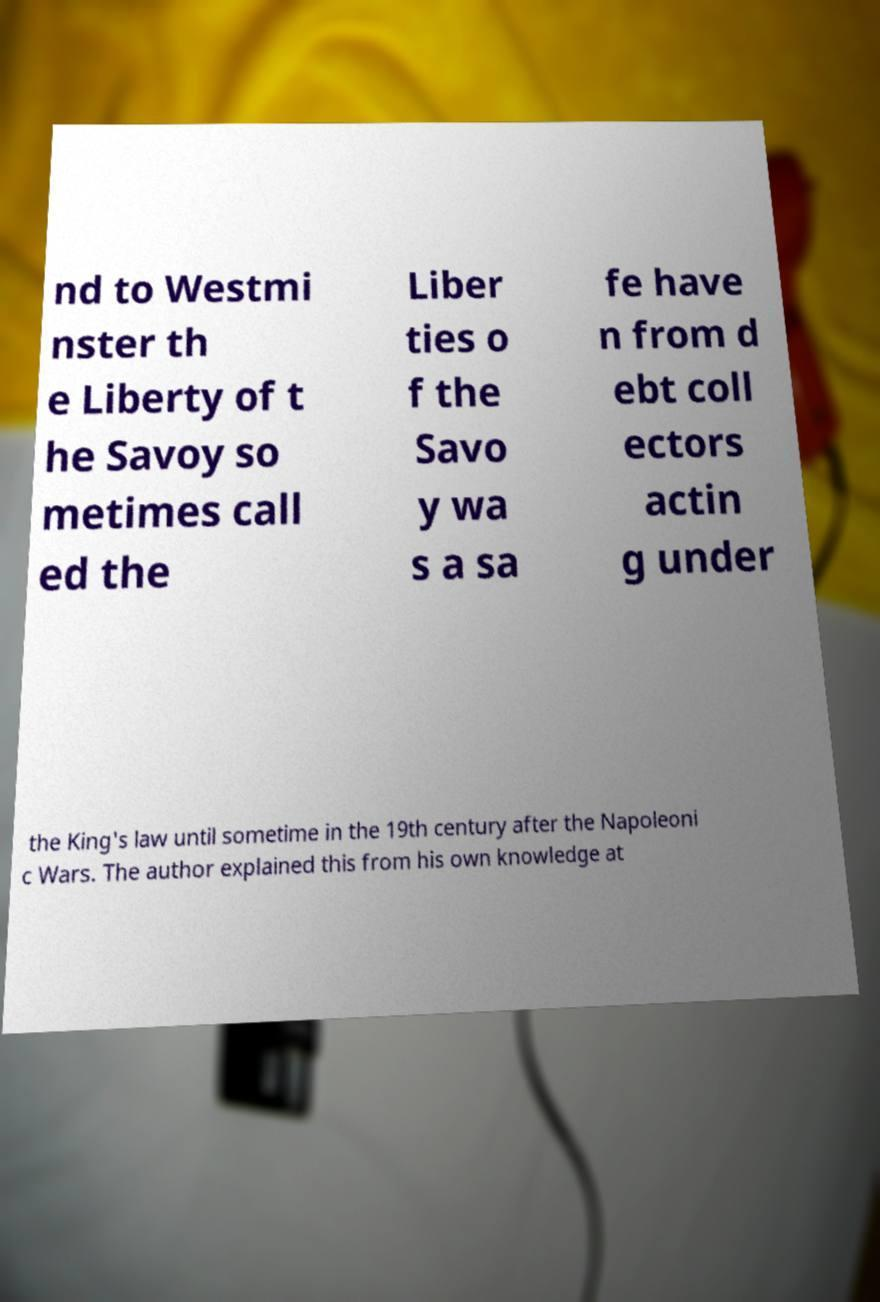Could you extract and type out the text from this image? nd to Westmi nster th e Liberty of t he Savoy so metimes call ed the Liber ties o f the Savo y wa s a sa fe have n from d ebt coll ectors actin g under the King's law until sometime in the 19th century after the Napoleoni c Wars. The author explained this from his own knowledge at 